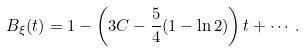<formula> <loc_0><loc_0><loc_500><loc_500>B _ { \xi } ( t ) = 1 - \left ( 3 C - \frac { 5 } { 4 } ( 1 - \ln 2 ) \right ) t + \cdots .</formula> 